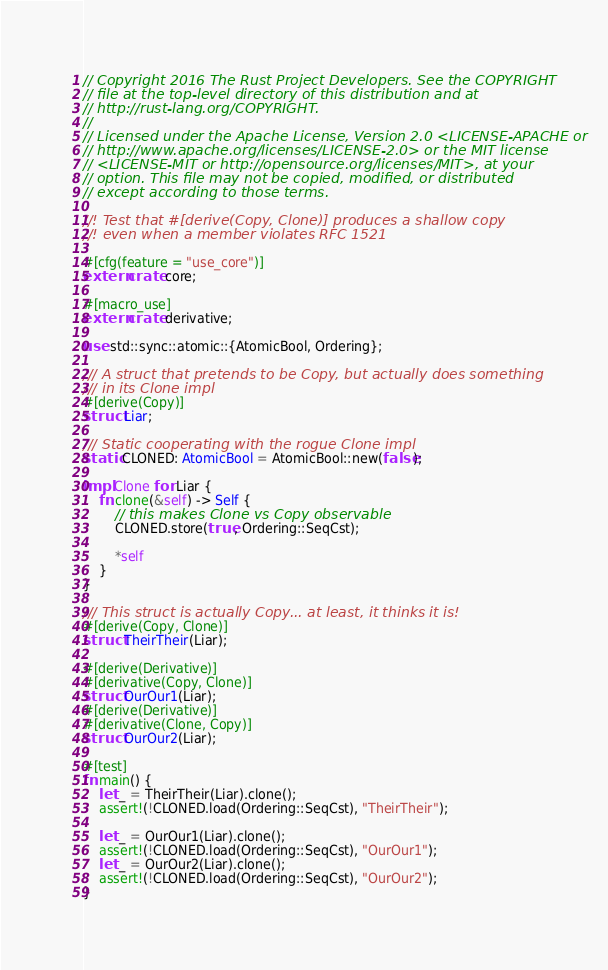<code> <loc_0><loc_0><loc_500><loc_500><_Rust_>// Copyright 2016 The Rust Project Developers. See the COPYRIGHT
// file at the top-level directory of this distribution and at
// http://rust-lang.org/COPYRIGHT.
//
// Licensed under the Apache License, Version 2.0 <LICENSE-APACHE or
// http://www.apache.org/licenses/LICENSE-2.0> or the MIT license
// <LICENSE-MIT or http://opensource.org/licenses/MIT>, at your
// option. This file may not be copied, modified, or distributed
// except according to those terms.

//! Test that #[derive(Copy, Clone)] produces a shallow copy
//! even when a member violates RFC 1521

#[cfg(feature = "use_core")]
extern crate core;

#[macro_use]
extern crate derivative;

use std::sync::atomic::{AtomicBool, Ordering};

/// A struct that pretends to be Copy, but actually does something
/// in its Clone impl
#[derive(Copy)]
struct Liar;

/// Static cooperating with the rogue Clone impl
static CLONED: AtomicBool = AtomicBool::new(false);

impl Clone for Liar {
    fn clone(&self) -> Self {
        // this makes Clone vs Copy observable
        CLONED.store(true, Ordering::SeqCst);

        *self
    }
}

/// This struct is actually Copy... at least, it thinks it is!
#[derive(Copy, Clone)]
struct TheirTheir(Liar);

#[derive(Derivative)]
#[derivative(Copy, Clone)]
struct OurOur1(Liar);
#[derive(Derivative)]
#[derivative(Clone, Copy)]
struct OurOur2(Liar);

#[test]
fn main() {
    let _ = TheirTheir(Liar).clone();
    assert!(!CLONED.load(Ordering::SeqCst), "TheirTheir");

    let _ = OurOur1(Liar).clone();
    assert!(!CLONED.load(Ordering::SeqCst), "OurOur1");
    let _ = OurOur2(Liar).clone();
    assert!(!CLONED.load(Ordering::SeqCst), "OurOur2");
}
</code> 